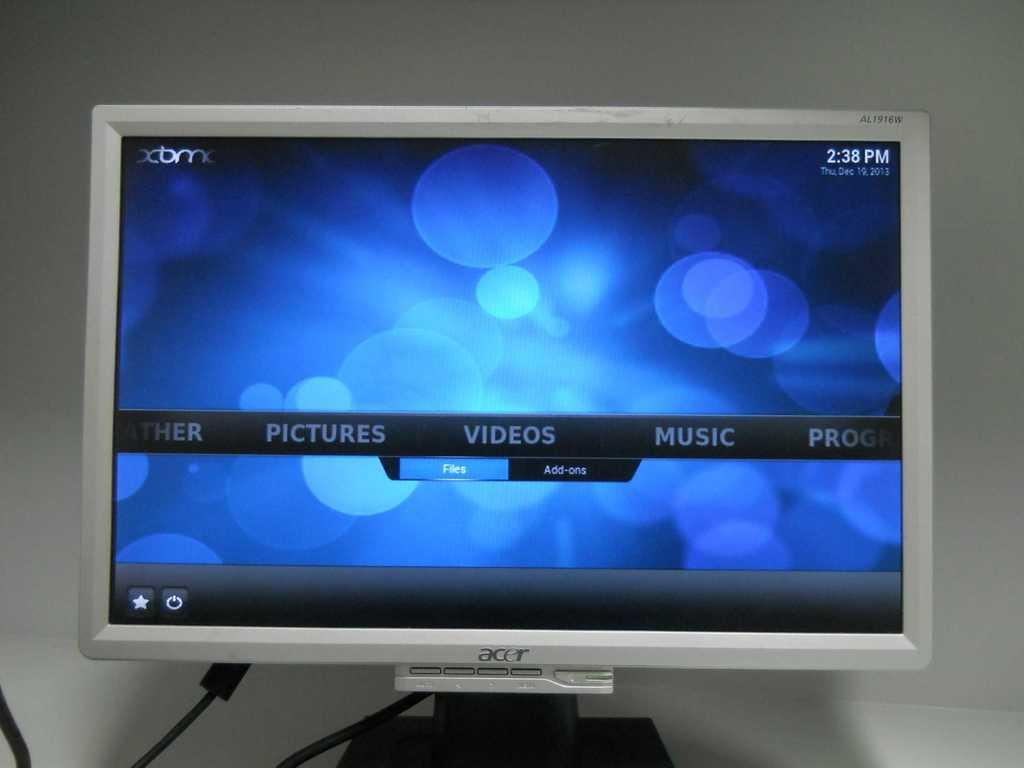<image>
Offer a succinct explanation of the picture presented. a screen that says videos on it with a silver bordee 